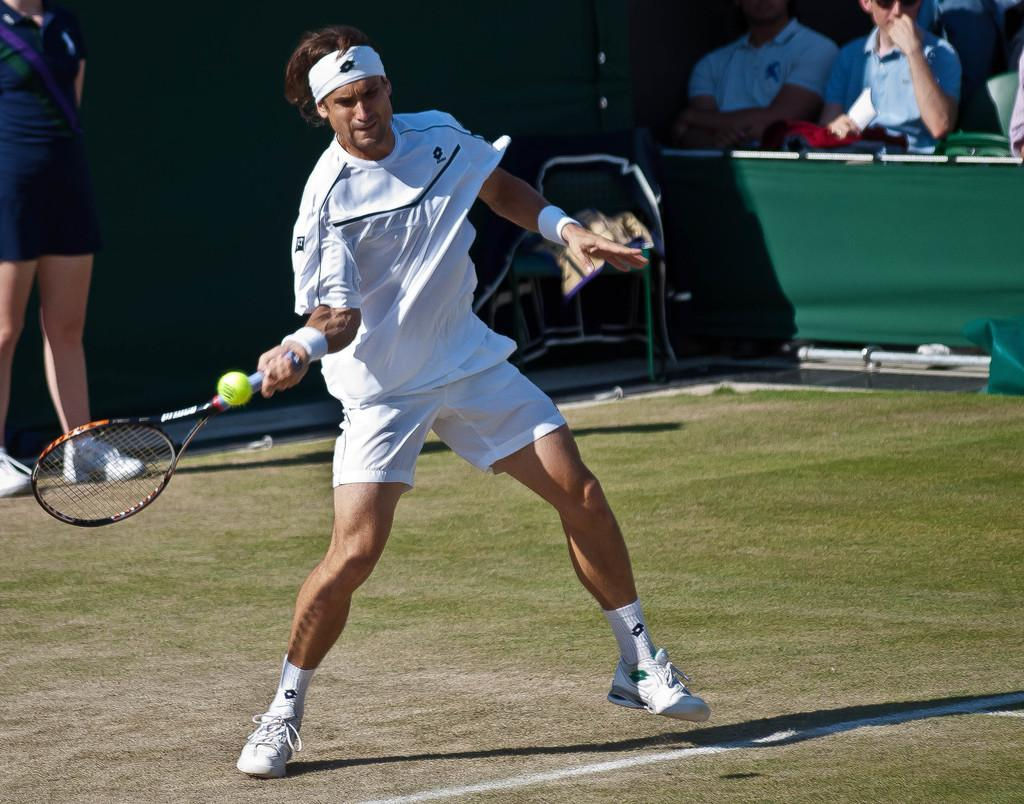What is the person in the image holding? The person is holding a bat. What can be seen in the background of the image? There are other persons visible in the background of the image, as well as a cloth. How many people are present in the image? There is at least one person holding a bat, and there are other persons visible in the background, so there are multiple people present in the image. What type of rod can be seen in the image? There is no rod present in the image. What kind of stone is visible in the background of the image? There is no stone visible in the image. 